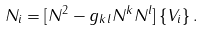<formula> <loc_0><loc_0><loc_500><loc_500>N _ { i } = [ N ^ { 2 } - g _ { k l } N ^ { k } N ^ { l } ] \left \{ V _ { i } \right \} .</formula> 